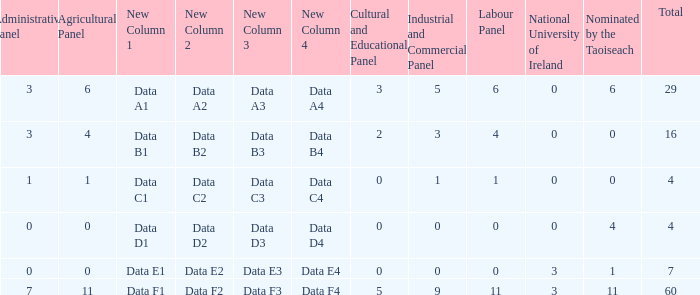What is the highest number of nominations by Taoiseach of the composition with an administrative panel greater than 0 and an industrial and commercial panel less than 1? None. 